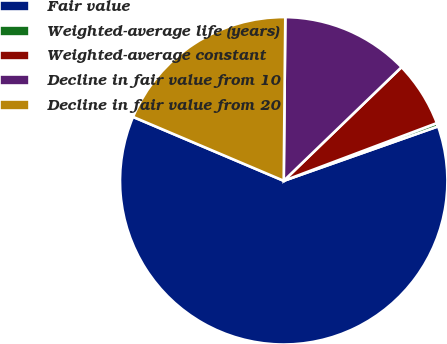Convert chart to OTSL. <chart><loc_0><loc_0><loc_500><loc_500><pie_chart><fcel>Fair value<fcel>Weighted-average life (years)<fcel>Weighted-average constant<fcel>Decline in fair value from 10<fcel>Decline in fair value from 20<nl><fcel>61.78%<fcel>0.34%<fcel>6.48%<fcel>12.63%<fcel>18.77%<nl></chart> 